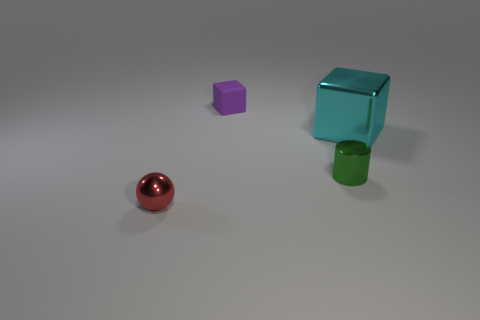Add 1 blocks. How many objects exist? 5 Subtract all cylinders. How many objects are left? 3 Subtract 0 yellow blocks. How many objects are left? 4 Subtract all gray blocks. Subtract all large cyan shiny things. How many objects are left? 3 Add 1 tiny matte blocks. How many tiny matte blocks are left? 2 Add 3 small things. How many small things exist? 6 